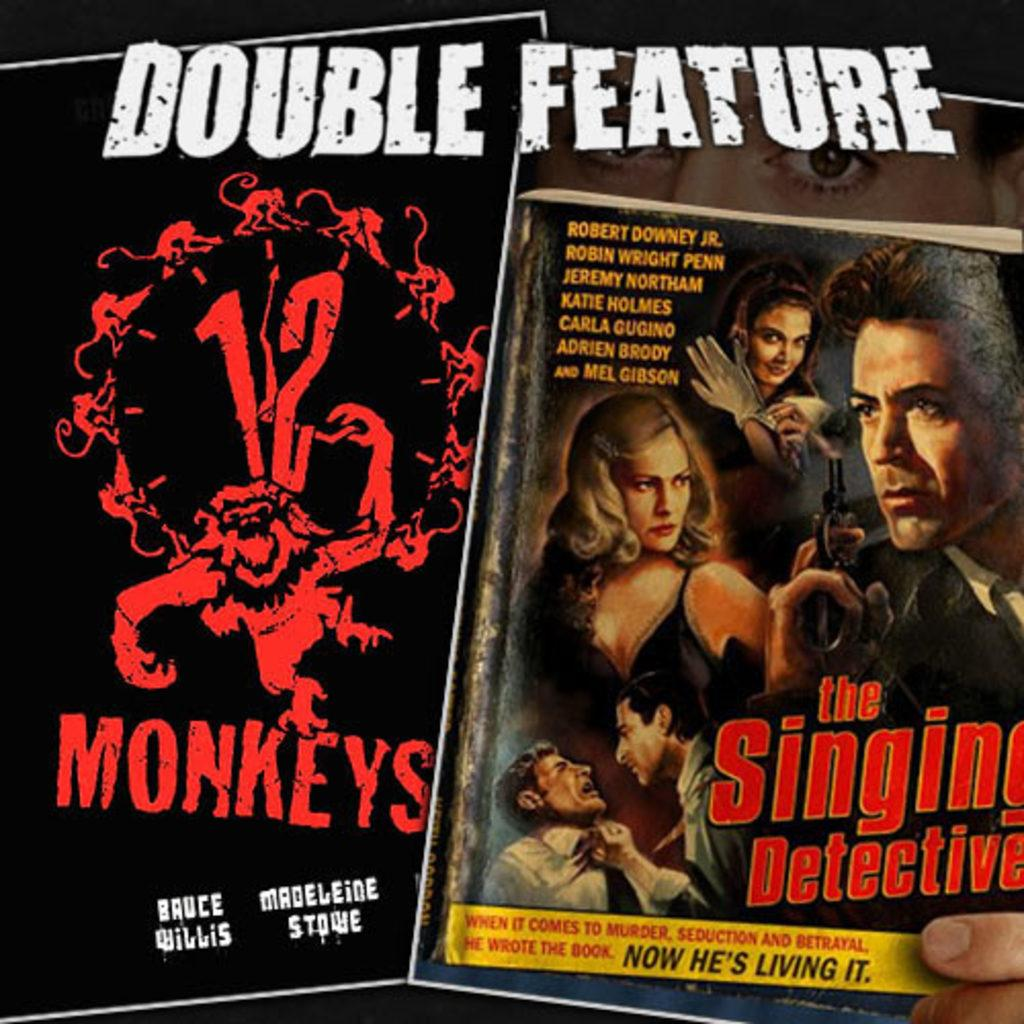<image>
Write a terse but informative summary of the picture. A book called the Singing Detective as part of a "Double feature" 